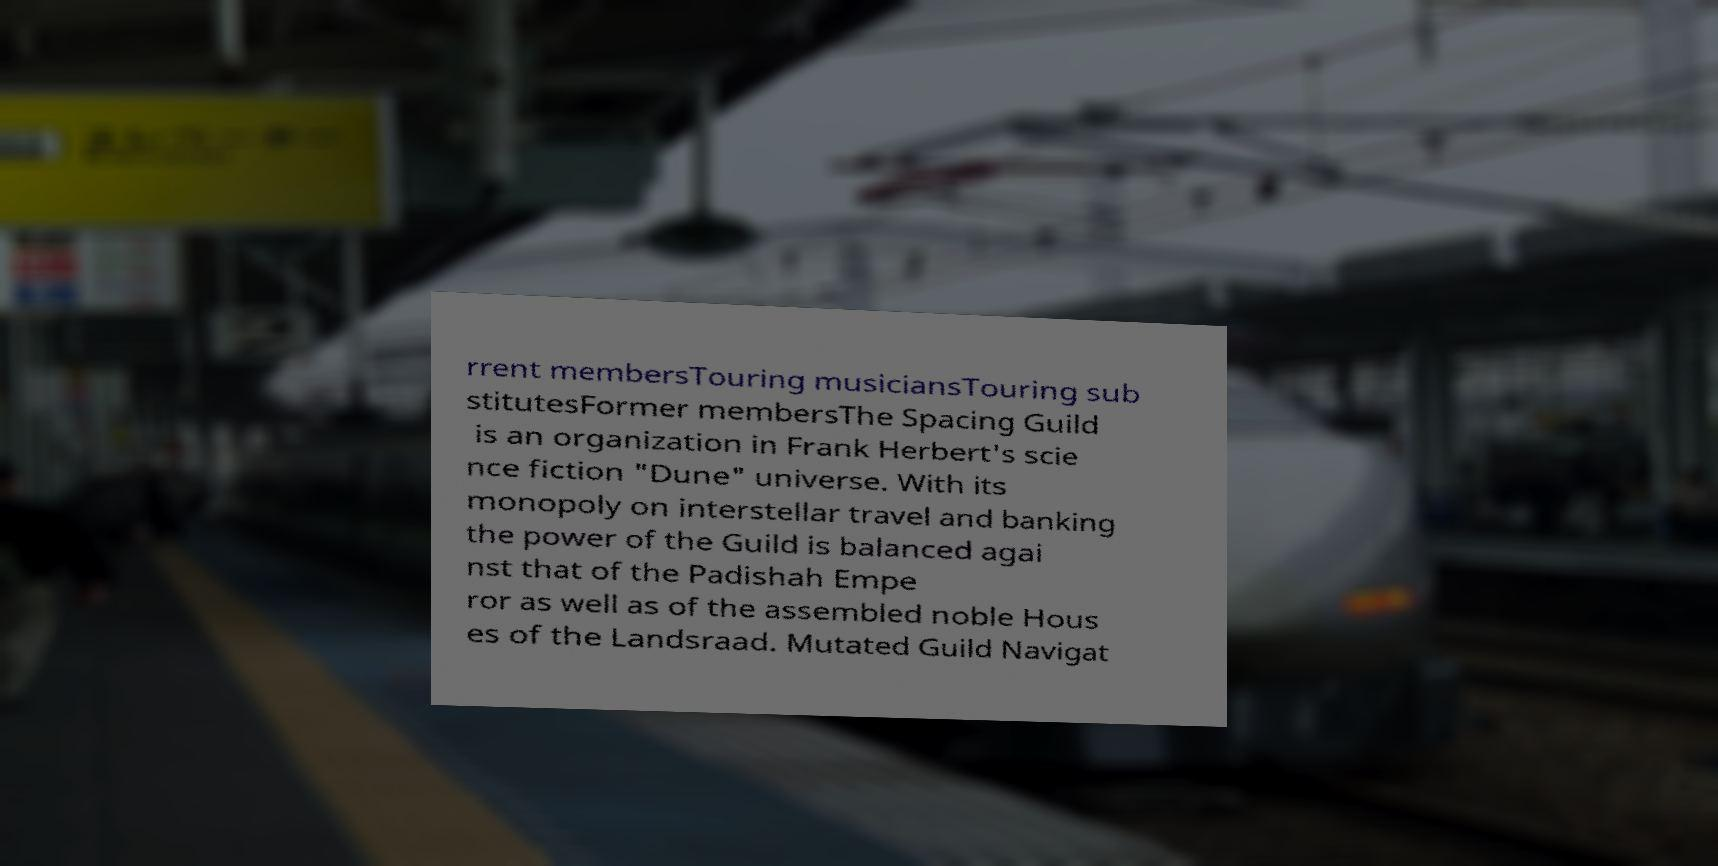Could you extract and type out the text from this image? rrent membersTouring musiciansTouring sub stitutesFormer membersThe Spacing Guild is an organization in Frank Herbert's scie nce fiction "Dune" universe. With its monopoly on interstellar travel and banking the power of the Guild is balanced agai nst that of the Padishah Empe ror as well as of the assembled noble Hous es of the Landsraad. Mutated Guild Navigat 